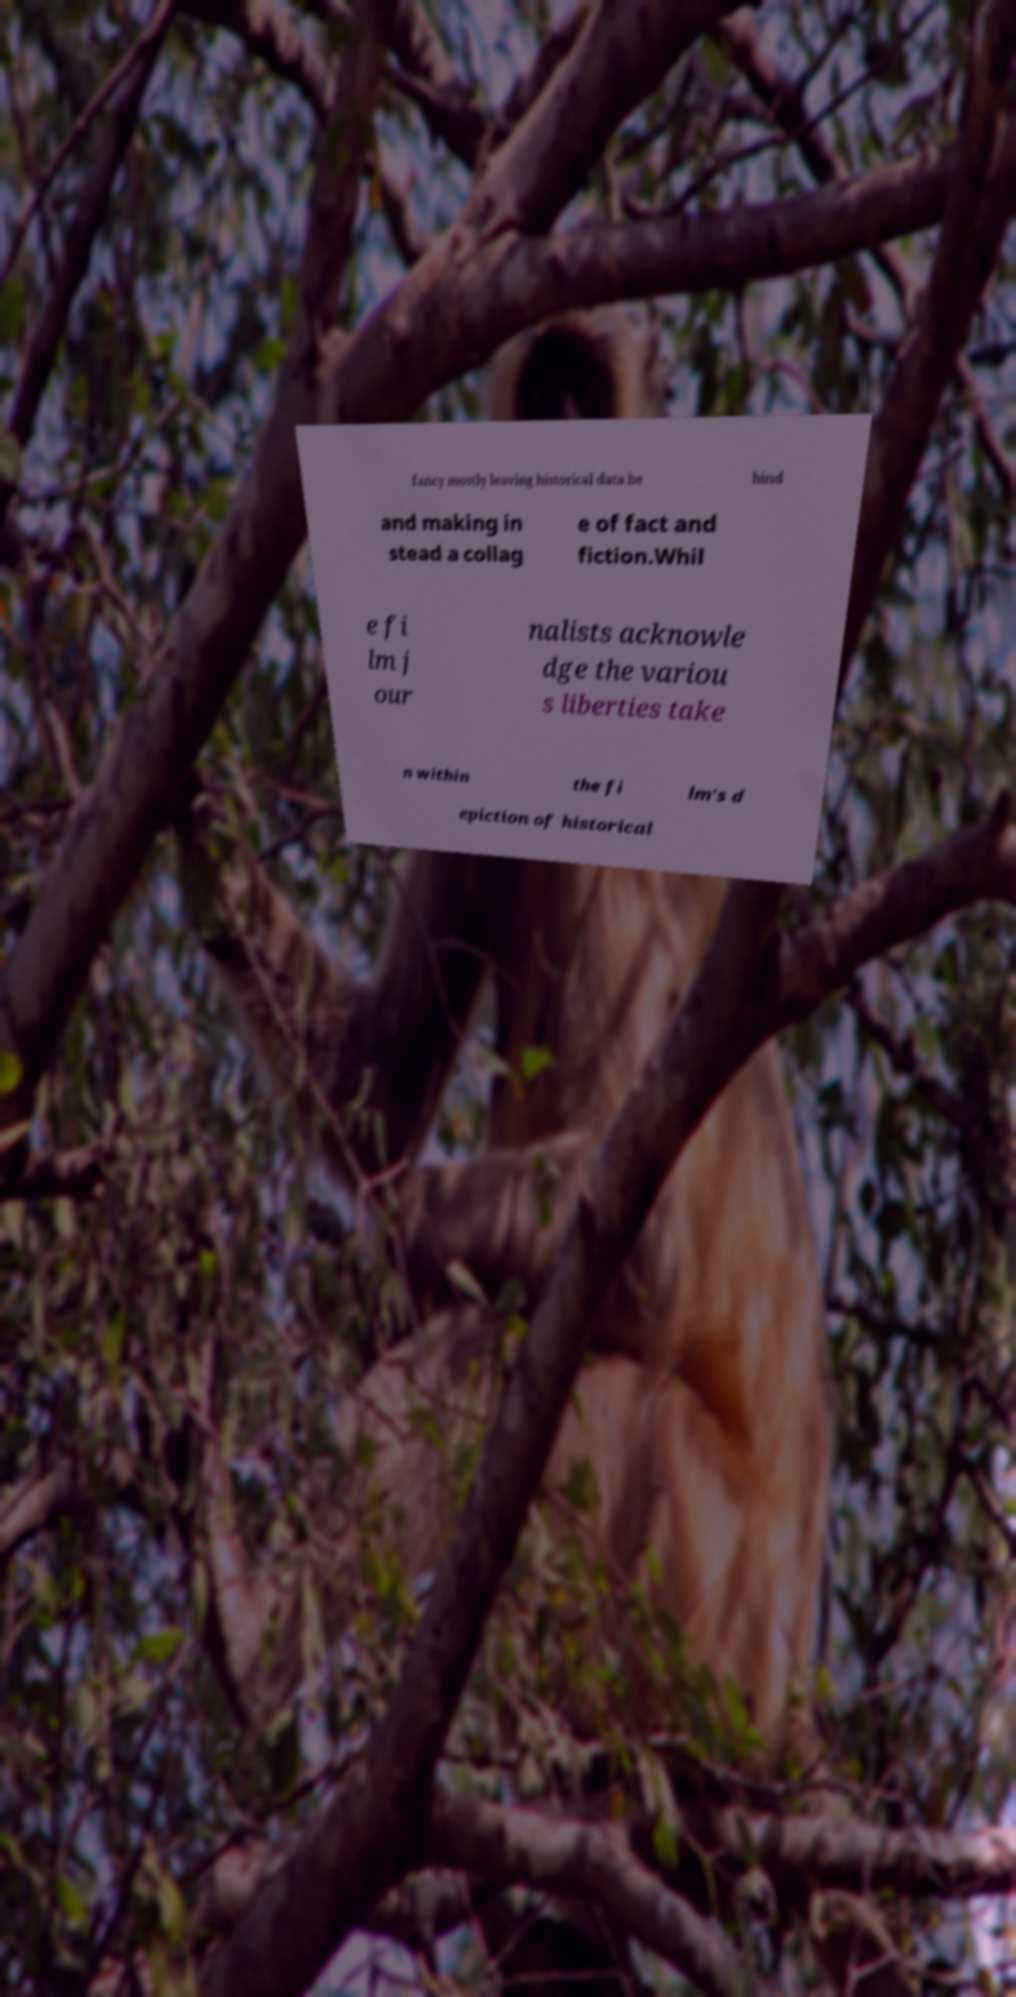Could you assist in decoding the text presented in this image and type it out clearly? fancy mostly leaving historical data be hind and making in stead a collag e of fact and fiction.Whil e fi lm j our nalists acknowle dge the variou s liberties take n within the fi lm's d epiction of historical 